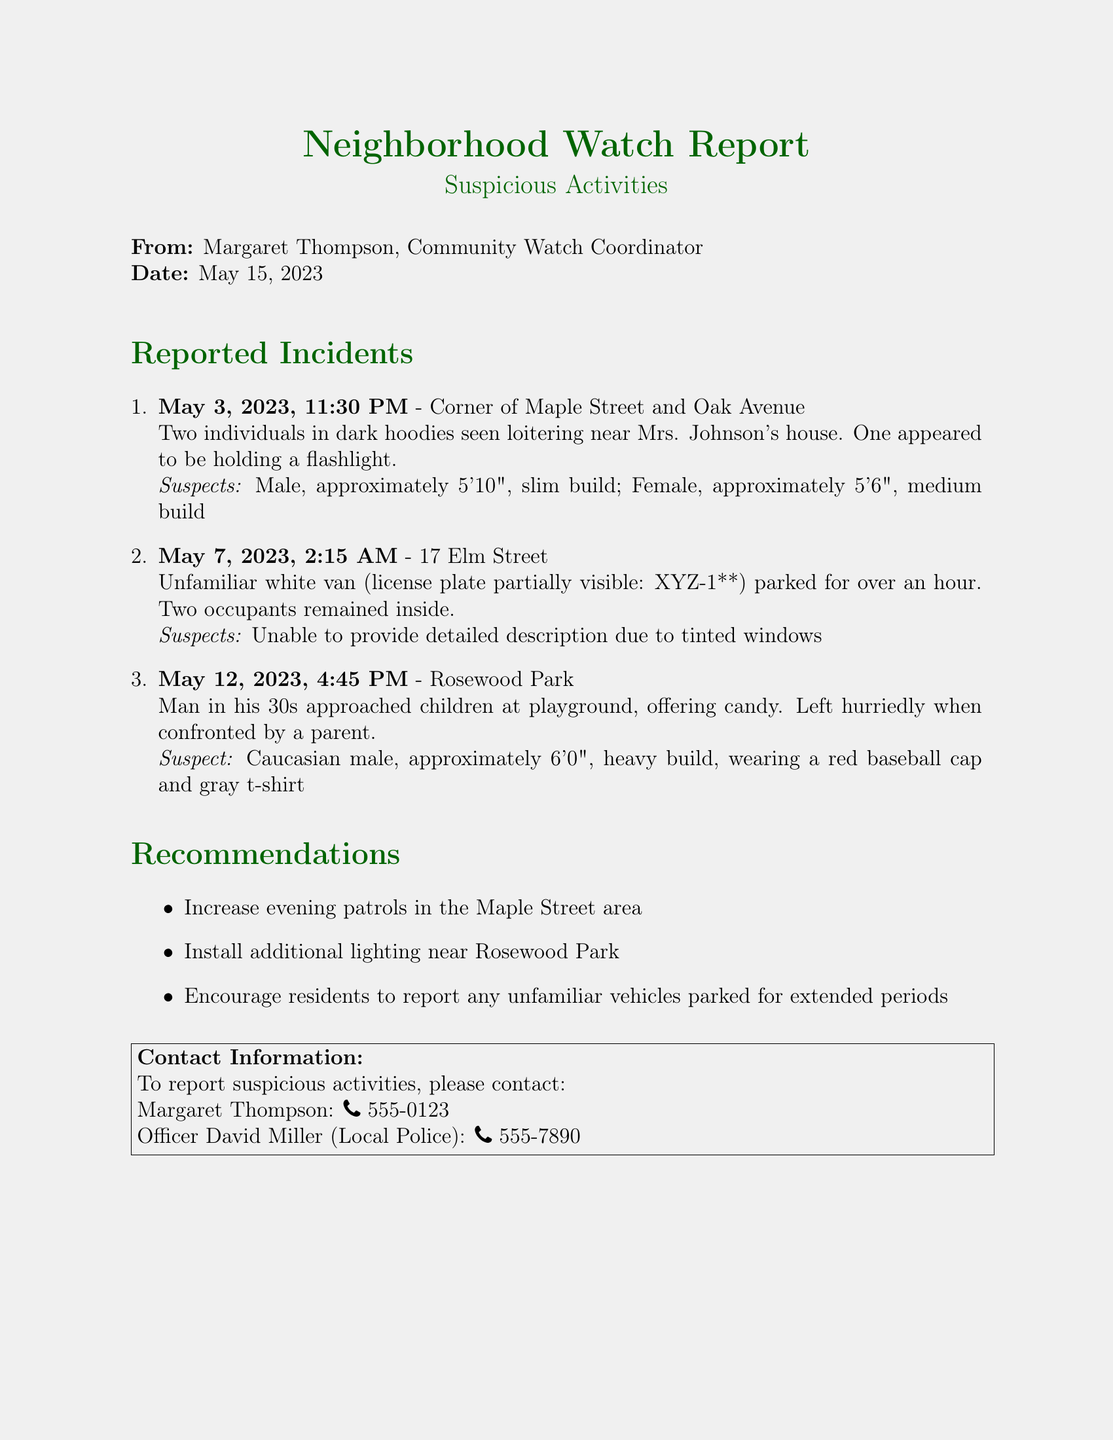What is the date of the report? The report is dated May 15, 2023.
Answer: May 15, 2023 How many incidents are reported? There are three incidents detailed in the report.
Answer: Three What was suspicious about the individuals on May 3, 2023? Two individuals were seen loitering near a house, one holding a flashlight.
Answer: Loitering near a house What was the description of the male suspect on May 12, 2023? The male suspect was described as Caucasian, approximately 6'0", heavy build, wearing a red baseball cap and gray t-shirt.
Answer: Caucasian, approximately 6'0", heavy build What is one recommendation made in the report? One recommendation is to increase evening patrols in the Maple Street area.
Answer: Increase evening patrols What was the time of the incident on May 7, 2023? The incident on May 7, 2023, occurred at 2:15 AM.
Answer: 2:15 AM What type of vehicle was reported on May 7, 2023? A white van was reported as suspicious.
Answer: White van Who should be contacted to report suspicious activities? Residents are advised to contact Margaret Thompson.
Answer: Margaret Thompson 